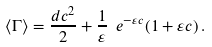Convert formula to latex. <formula><loc_0><loc_0><loc_500><loc_500>\langle \Gamma \rangle = \frac { d c ^ { 2 } } { 2 } + \frac { 1 } { \varepsilon } \ e ^ { - \varepsilon c } ( 1 + \varepsilon c ) \, .</formula> 